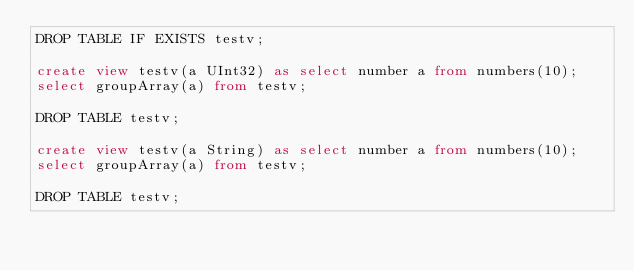Convert code to text. <code><loc_0><loc_0><loc_500><loc_500><_SQL_>DROP TABLE IF EXISTS testv;

create view testv(a UInt32) as select number a from numbers(10);
select groupArray(a) from testv;

DROP TABLE testv;

create view testv(a String) as select number a from numbers(10);
select groupArray(a) from testv;

DROP TABLE testv;
</code> 